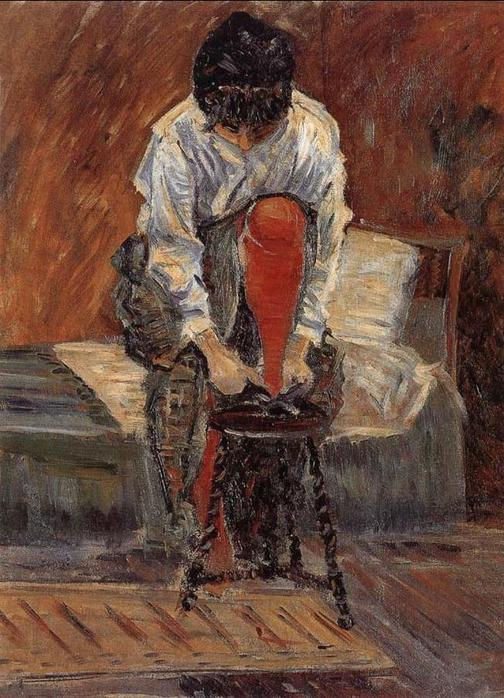Dwell into your wildest imagination and come up with a fantastical scenario involving this image. As the woman ties her shoes, she feels a curious tingle in her fingers. The room begins to shimmer, and the once-solid floor turns transparent, revealing a hidden galaxy beneath. She is no ordinary woman; she is a guardian of celestial secrets, and her humble room is a portal to otherworldly realms. With each lace she ties, a star appears below, forming constellations. The chair morphs into a throne, and the bed transforms into a floating cloud. She stands up, ready to embark on a journey through the stars, guided by the ancient wisdom she carries within. 